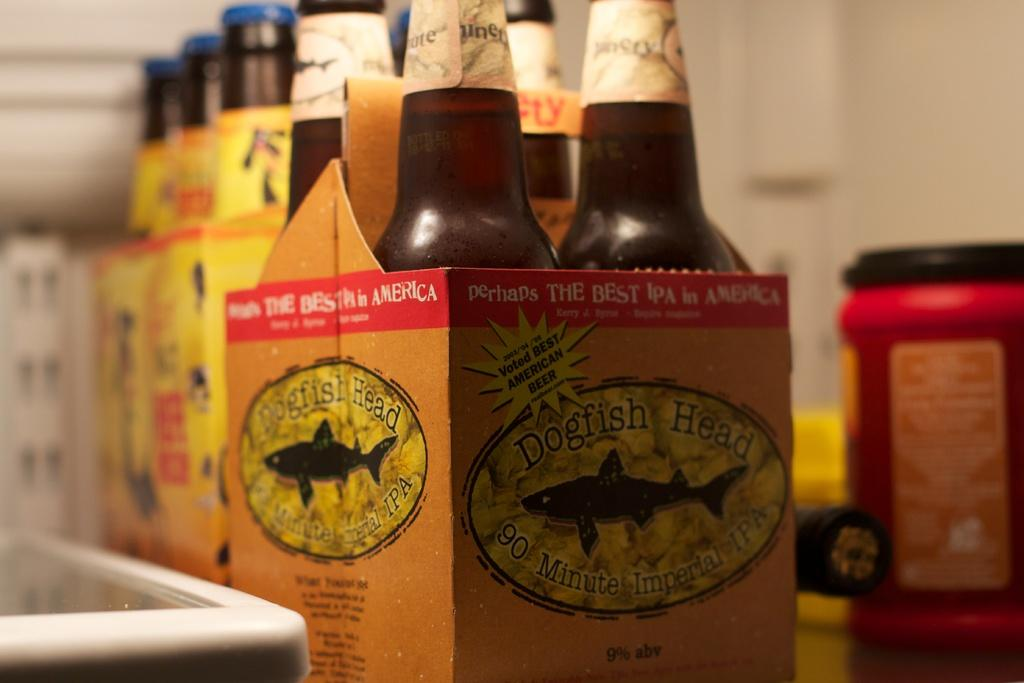What can be found inside the boxes in the image? There are bottles in the boxes in the image. What is located in the background of the image? There is a jar and other objects visible in the background of the image. What is the setting of the image? There is a wall in the image, suggesting an indoor setting. What type of apples can be seen growing in the garden in the image? There is no garden or apples present in the image. 